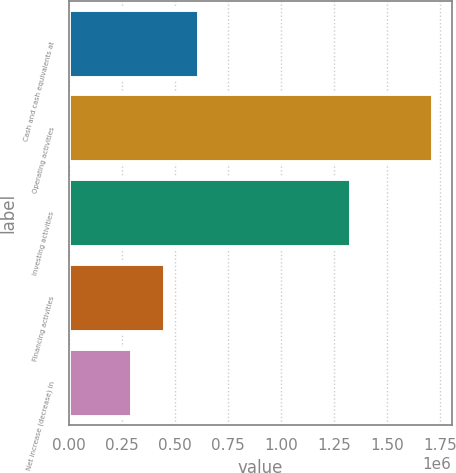<chart> <loc_0><loc_0><loc_500><loc_500><bar_chart><fcel>Cash and cash equivalents at<fcel>Operating activities<fcel>Investing activities<fcel>Financing activities<fcel>Net increase (decrease) in<nl><fcel>613289<fcel>1.71859e+06<fcel>1.33004e+06<fcel>455389<fcel>297488<nl></chart> 